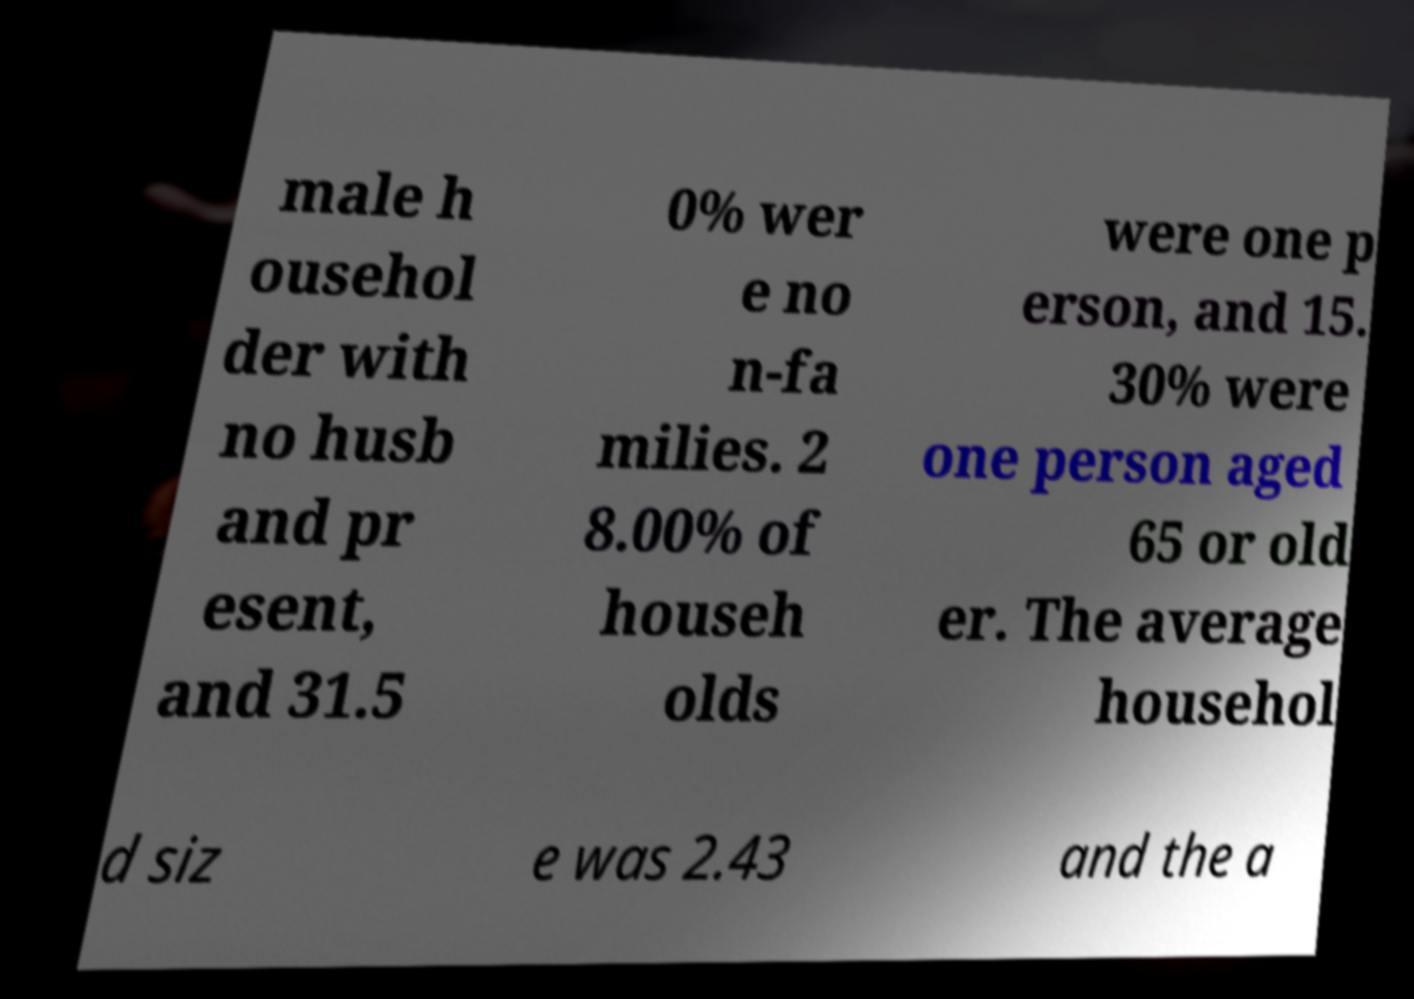For documentation purposes, I need the text within this image transcribed. Could you provide that? male h ousehol der with no husb and pr esent, and 31.5 0% wer e no n-fa milies. 2 8.00% of househ olds were one p erson, and 15. 30% were one person aged 65 or old er. The average househol d siz e was 2.43 and the a 